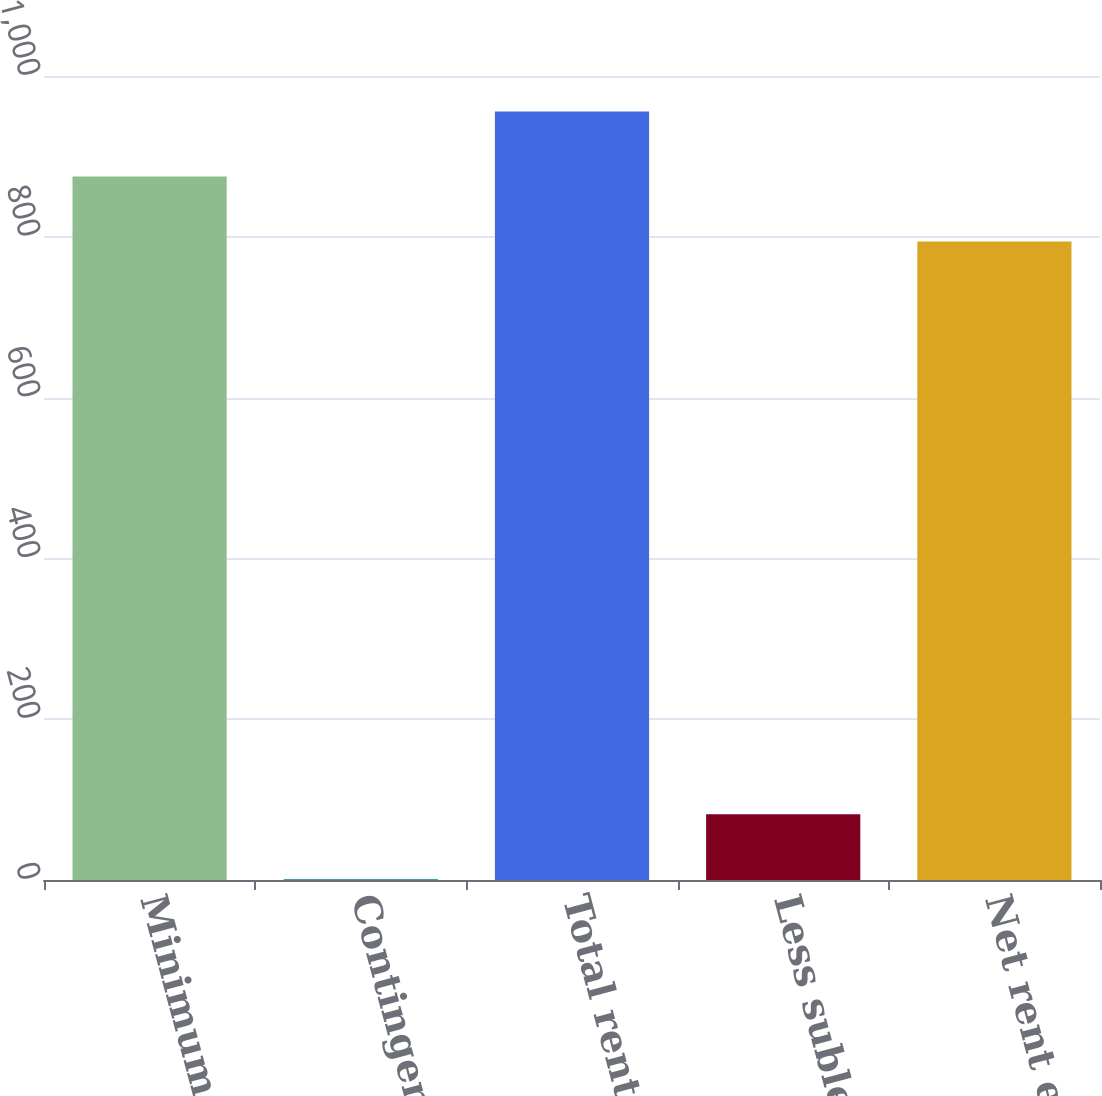Convert chart. <chart><loc_0><loc_0><loc_500><loc_500><bar_chart><fcel>Minimum rentals<fcel>Contingent rentals<fcel>Total rent expense<fcel>Less sublease income<fcel>Net rent expense<nl><fcel>874.9<fcel>1<fcel>955.8<fcel>81.9<fcel>794<nl></chart> 